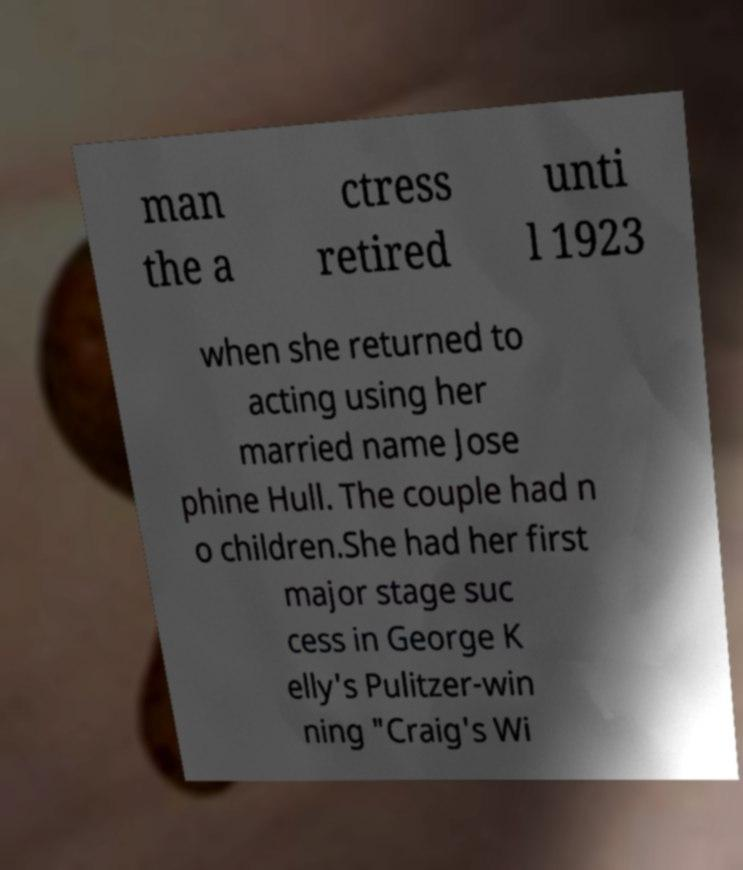Can you accurately transcribe the text from the provided image for me? man the a ctress retired unti l 1923 when she returned to acting using her married name Jose phine Hull. The couple had n o children.She had her first major stage suc cess in George K elly's Pulitzer-win ning "Craig's Wi 